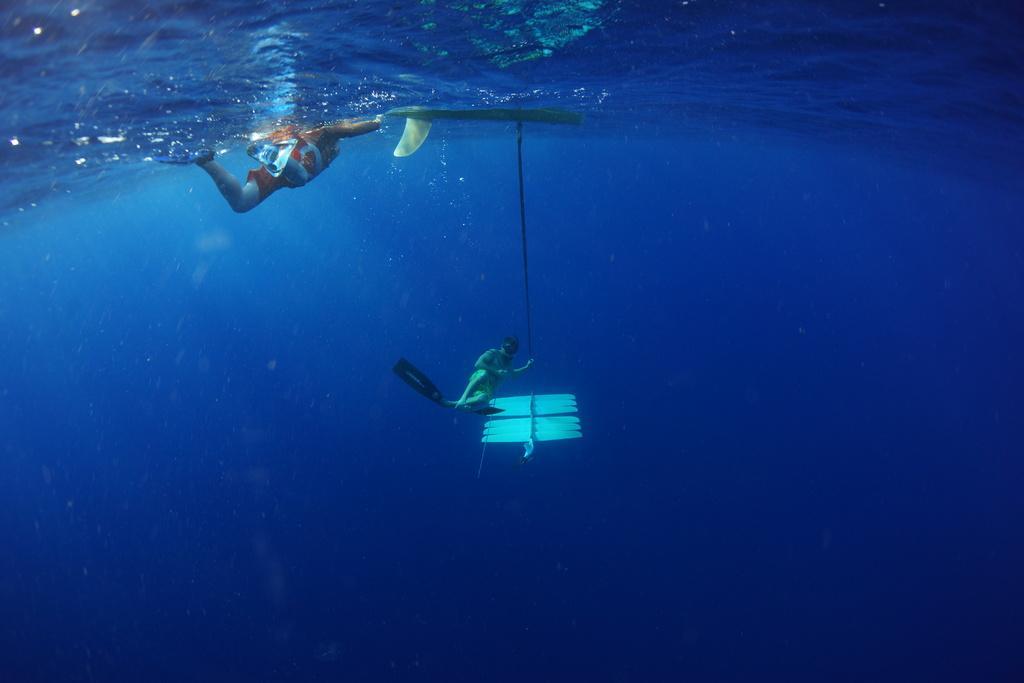In one or two sentences, can you explain what this image depicts? In this image we can see two persons driving under the water. 